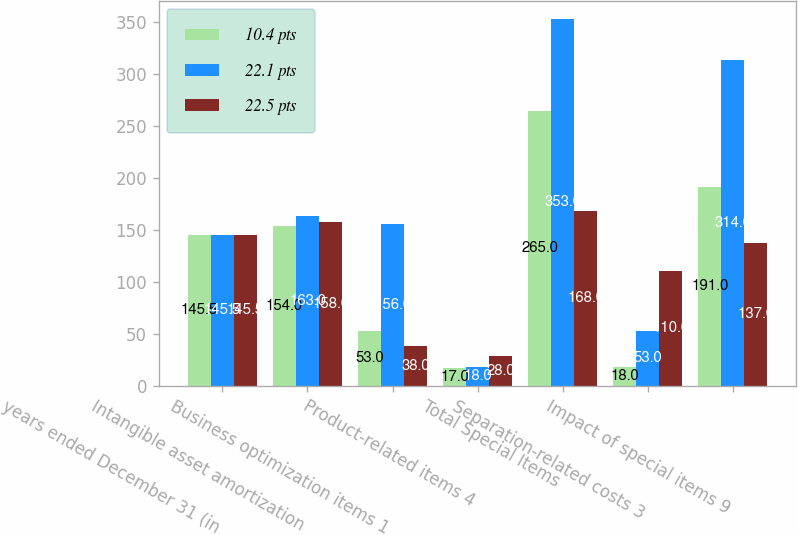<chart> <loc_0><loc_0><loc_500><loc_500><stacked_bar_chart><ecel><fcel>years ended December 31 (in<fcel>Intangible asset amortization<fcel>Business optimization items 1<fcel>Product-related items 4<fcel>Total Special Items<fcel>Separation-related costs 3<fcel>Impact of special items 9<nl><fcel>10.4 pts<fcel>145.5<fcel>154<fcel>53<fcel>17<fcel>265<fcel>18<fcel>191<nl><fcel>22.1 pts<fcel>145.5<fcel>163<fcel>156<fcel>18<fcel>353<fcel>53<fcel>314<nl><fcel>22.5 pts<fcel>145.5<fcel>158<fcel>38<fcel>28<fcel>168<fcel>110<fcel>137<nl></chart> 